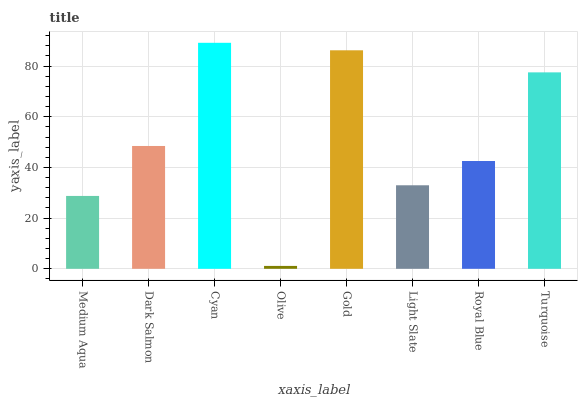Is Olive the minimum?
Answer yes or no. Yes. Is Cyan the maximum?
Answer yes or no. Yes. Is Dark Salmon the minimum?
Answer yes or no. No. Is Dark Salmon the maximum?
Answer yes or no. No. Is Dark Salmon greater than Medium Aqua?
Answer yes or no. Yes. Is Medium Aqua less than Dark Salmon?
Answer yes or no. Yes. Is Medium Aqua greater than Dark Salmon?
Answer yes or no. No. Is Dark Salmon less than Medium Aqua?
Answer yes or no. No. Is Dark Salmon the high median?
Answer yes or no. Yes. Is Royal Blue the low median?
Answer yes or no. Yes. Is Medium Aqua the high median?
Answer yes or no. No. Is Turquoise the low median?
Answer yes or no. No. 